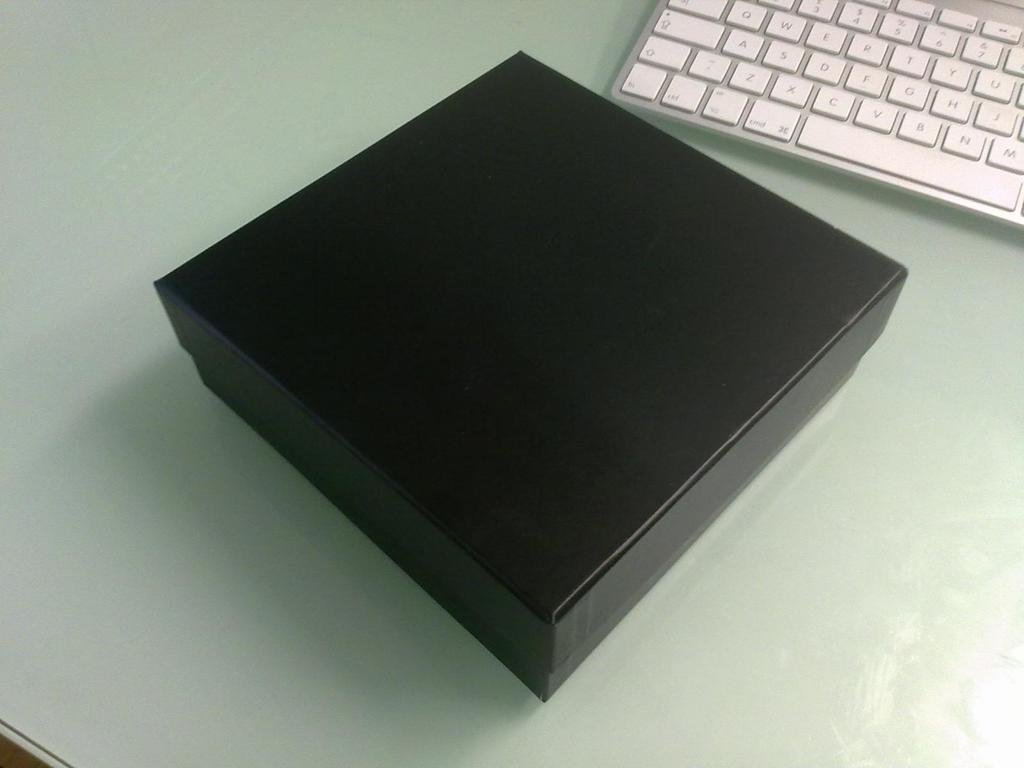<image>
Summarize the visual content of the image. A row of letters shown on the keyboard is A, S, D,F G, H J, 